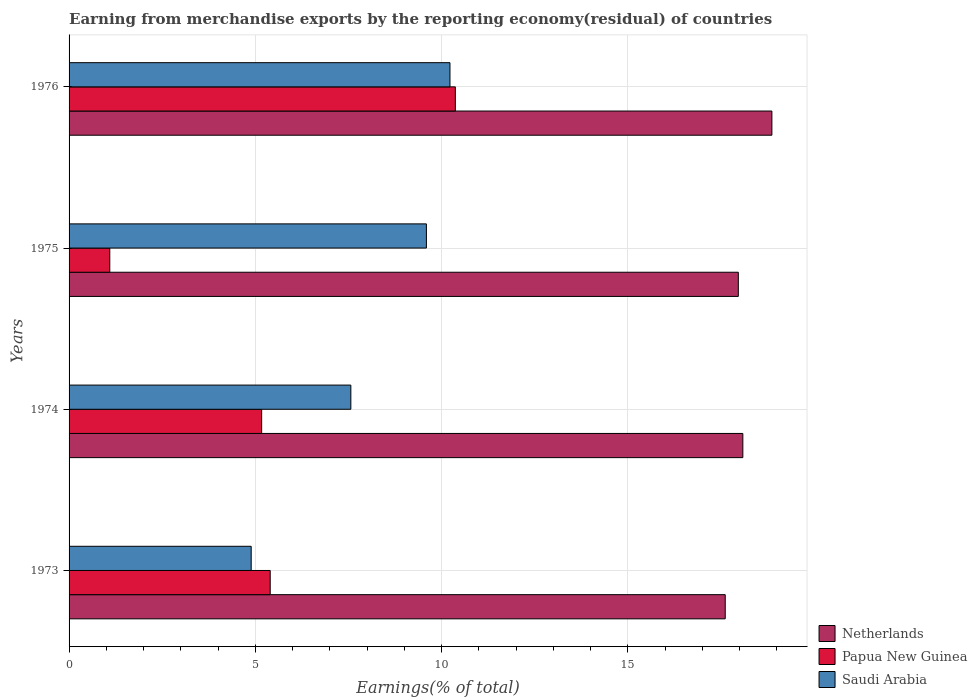How many groups of bars are there?
Give a very brief answer. 4. Are the number of bars per tick equal to the number of legend labels?
Your response must be concise. Yes. How many bars are there on the 1st tick from the top?
Ensure brevity in your answer.  3. What is the label of the 1st group of bars from the top?
Offer a very short reply. 1976. In how many cases, is the number of bars for a given year not equal to the number of legend labels?
Keep it short and to the point. 0. What is the percentage of amount earned from merchandise exports in Saudi Arabia in 1976?
Keep it short and to the point. 10.23. Across all years, what is the maximum percentage of amount earned from merchandise exports in Saudi Arabia?
Your answer should be very brief. 10.23. Across all years, what is the minimum percentage of amount earned from merchandise exports in Netherlands?
Your response must be concise. 17.62. In which year was the percentage of amount earned from merchandise exports in Netherlands maximum?
Provide a succinct answer. 1976. In which year was the percentage of amount earned from merchandise exports in Papua New Guinea minimum?
Ensure brevity in your answer.  1975. What is the total percentage of amount earned from merchandise exports in Papua New Guinea in the graph?
Your response must be concise. 22.03. What is the difference between the percentage of amount earned from merchandise exports in Netherlands in 1974 and that in 1976?
Your response must be concise. -0.78. What is the difference between the percentage of amount earned from merchandise exports in Netherlands in 1975 and the percentage of amount earned from merchandise exports in Papua New Guinea in 1976?
Make the answer very short. 7.6. What is the average percentage of amount earned from merchandise exports in Saudi Arabia per year?
Keep it short and to the point. 8.07. In the year 1974, what is the difference between the percentage of amount earned from merchandise exports in Papua New Guinea and percentage of amount earned from merchandise exports in Saudi Arabia?
Provide a short and direct response. -2.39. In how many years, is the percentage of amount earned from merchandise exports in Netherlands greater than 5 %?
Keep it short and to the point. 4. What is the ratio of the percentage of amount earned from merchandise exports in Netherlands in 1973 to that in 1975?
Make the answer very short. 0.98. What is the difference between the highest and the second highest percentage of amount earned from merchandise exports in Saudi Arabia?
Keep it short and to the point. 0.63. What is the difference between the highest and the lowest percentage of amount earned from merchandise exports in Saudi Arabia?
Your answer should be very brief. 5.34. What does the 1st bar from the top in 1976 represents?
Ensure brevity in your answer.  Saudi Arabia. What does the 2nd bar from the bottom in 1976 represents?
Provide a succinct answer. Papua New Guinea. How many bars are there?
Make the answer very short. 12. How many years are there in the graph?
Provide a short and direct response. 4. What is the difference between two consecutive major ticks on the X-axis?
Your response must be concise. 5. Does the graph contain any zero values?
Ensure brevity in your answer.  No. Does the graph contain grids?
Your answer should be very brief. Yes. How many legend labels are there?
Keep it short and to the point. 3. What is the title of the graph?
Your answer should be very brief. Earning from merchandise exports by the reporting economy(residual) of countries. What is the label or title of the X-axis?
Your response must be concise. Earnings(% of total). What is the label or title of the Y-axis?
Your answer should be very brief. Years. What is the Earnings(% of total) in Netherlands in 1973?
Your answer should be very brief. 17.62. What is the Earnings(% of total) of Papua New Guinea in 1973?
Provide a short and direct response. 5.4. What is the Earnings(% of total) of Saudi Arabia in 1973?
Keep it short and to the point. 4.89. What is the Earnings(% of total) of Netherlands in 1974?
Your answer should be very brief. 18.09. What is the Earnings(% of total) in Papua New Guinea in 1974?
Your answer should be compact. 5.17. What is the Earnings(% of total) in Saudi Arabia in 1974?
Keep it short and to the point. 7.56. What is the Earnings(% of total) in Netherlands in 1975?
Your response must be concise. 17.97. What is the Earnings(% of total) of Papua New Guinea in 1975?
Your response must be concise. 1.09. What is the Earnings(% of total) of Saudi Arabia in 1975?
Give a very brief answer. 9.59. What is the Earnings(% of total) of Netherlands in 1976?
Your response must be concise. 18.87. What is the Earnings(% of total) of Papua New Guinea in 1976?
Give a very brief answer. 10.37. What is the Earnings(% of total) in Saudi Arabia in 1976?
Provide a succinct answer. 10.23. Across all years, what is the maximum Earnings(% of total) in Netherlands?
Ensure brevity in your answer.  18.87. Across all years, what is the maximum Earnings(% of total) of Papua New Guinea?
Provide a succinct answer. 10.37. Across all years, what is the maximum Earnings(% of total) of Saudi Arabia?
Provide a succinct answer. 10.23. Across all years, what is the minimum Earnings(% of total) of Netherlands?
Offer a very short reply. 17.62. Across all years, what is the minimum Earnings(% of total) in Papua New Guinea?
Keep it short and to the point. 1.09. Across all years, what is the minimum Earnings(% of total) in Saudi Arabia?
Your response must be concise. 4.89. What is the total Earnings(% of total) of Netherlands in the graph?
Make the answer very short. 72.54. What is the total Earnings(% of total) in Papua New Guinea in the graph?
Provide a succinct answer. 22.03. What is the total Earnings(% of total) of Saudi Arabia in the graph?
Give a very brief answer. 32.27. What is the difference between the Earnings(% of total) of Netherlands in 1973 and that in 1974?
Provide a short and direct response. -0.47. What is the difference between the Earnings(% of total) of Papua New Guinea in 1973 and that in 1974?
Keep it short and to the point. 0.23. What is the difference between the Earnings(% of total) of Saudi Arabia in 1973 and that in 1974?
Provide a short and direct response. -2.68. What is the difference between the Earnings(% of total) of Netherlands in 1973 and that in 1975?
Give a very brief answer. -0.35. What is the difference between the Earnings(% of total) of Papua New Guinea in 1973 and that in 1975?
Provide a succinct answer. 4.31. What is the difference between the Earnings(% of total) in Saudi Arabia in 1973 and that in 1975?
Ensure brevity in your answer.  -4.7. What is the difference between the Earnings(% of total) of Netherlands in 1973 and that in 1976?
Your answer should be compact. -1.25. What is the difference between the Earnings(% of total) of Papua New Guinea in 1973 and that in 1976?
Your response must be concise. -4.97. What is the difference between the Earnings(% of total) in Saudi Arabia in 1973 and that in 1976?
Offer a terse response. -5.34. What is the difference between the Earnings(% of total) of Netherlands in 1974 and that in 1975?
Make the answer very short. 0.12. What is the difference between the Earnings(% of total) of Papua New Guinea in 1974 and that in 1975?
Your response must be concise. 4.08. What is the difference between the Earnings(% of total) in Saudi Arabia in 1974 and that in 1975?
Offer a very short reply. -2.03. What is the difference between the Earnings(% of total) of Netherlands in 1974 and that in 1976?
Offer a very short reply. -0.78. What is the difference between the Earnings(% of total) of Papua New Guinea in 1974 and that in 1976?
Ensure brevity in your answer.  -5.2. What is the difference between the Earnings(% of total) of Saudi Arabia in 1974 and that in 1976?
Offer a terse response. -2.66. What is the difference between the Earnings(% of total) of Netherlands in 1975 and that in 1976?
Provide a short and direct response. -0.9. What is the difference between the Earnings(% of total) in Papua New Guinea in 1975 and that in 1976?
Give a very brief answer. -9.28. What is the difference between the Earnings(% of total) of Saudi Arabia in 1975 and that in 1976?
Provide a short and direct response. -0.63. What is the difference between the Earnings(% of total) of Netherlands in 1973 and the Earnings(% of total) of Papua New Guinea in 1974?
Make the answer very short. 12.45. What is the difference between the Earnings(% of total) of Netherlands in 1973 and the Earnings(% of total) of Saudi Arabia in 1974?
Provide a short and direct response. 10.05. What is the difference between the Earnings(% of total) in Papua New Guinea in 1973 and the Earnings(% of total) in Saudi Arabia in 1974?
Give a very brief answer. -2.16. What is the difference between the Earnings(% of total) of Netherlands in 1973 and the Earnings(% of total) of Papua New Guinea in 1975?
Provide a succinct answer. 16.52. What is the difference between the Earnings(% of total) of Netherlands in 1973 and the Earnings(% of total) of Saudi Arabia in 1975?
Offer a very short reply. 8.02. What is the difference between the Earnings(% of total) of Papua New Guinea in 1973 and the Earnings(% of total) of Saudi Arabia in 1975?
Keep it short and to the point. -4.19. What is the difference between the Earnings(% of total) in Netherlands in 1973 and the Earnings(% of total) in Papua New Guinea in 1976?
Ensure brevity in your answer.  7.25. What is the difference between the Earnings(% of total) of Netherlands in 1973 and the Earnings(% of total) of Saudi Arabia in 1976?
Give a very brief answer. 7.39. What is the difference between the Earnings(% of total) in Papua New Guinea in 1973 and the Earnings(% of total) in Saudi Arabia in 1976?
Ensure brevity in your answer.  -4.83. What is the difference between the Earnings(% of total) of Netherlands in 1974 and the Earnings(% of total) of Papua New Guinea in 1975?
Your response must be concise. 17. What is the difference between the Earnings(% of total) in Netherlands in 1974 and the Earnings(% of total) in Saudi Arabia in 1975?
Your response must be concise. 8.5. What is the difference between the Earnings(% of total) of Papua New Guinea in 1974 and the Earnings(% of total) of Saudi Arabia in 1975?
Keep it short and to the point. -4.42. What is the difference between the Earnings(% of total) in Netherlands in 1974 and the Earnings(% of total) in Papua New Guinea in 1976?
Ensure brevity in your answer.  7.72. What is the difference between the Earnings(% of total) in Netherlands in 1974 and the Earnings(% of total) in Saudi Arabia in 1976?
Make the answer very short. 7.86. What is the difference between the Earnings(% of total) in Papua New Guinea in 1974 and the Earnings(% of total) in Saudi Arabia in 1976?
Offer a terse response. -5.06. What is the difference between the Earnings(% of total) of Netherlands in 1975 and the Earnings(% of total) of Papua New Guinea in 1976?
Keep it short and to the point. 7.6. What is the difference between the Earnings(% of total) of Netherlands in 1975 and the Earnings(% of total) of Saudi Arabia in 1976?
Provide a succinct answer. 7.74. What is the difference between the Earnings(% of total) of Papua New Guinea in 1975 and the Earnings(% of total) of Saudi Arabia in 1976?
Keep it short and to the point. -9.13. What is the average Earnings(% of total) in Netherlands per year?
Offer a terse response. 18.14. What is the average Earnings(% of total) of Papua New Guinea per year?
Make the answer very short. 5.51. What is the average Earnings(% of total) in Saudi Arabia per year?
Make the answer very short. 8.07. In the year 1973, what is the difference between the Earnings(% of total) in Netherlands and Earnings(% of total) in Papua New Guinea?
Your answer should be very brief. 12.22. In the year 1973, what is the difference between the Earnings(% of total) in Netherlands and Earnings(% of total) in Saudi Arabia?
Make the answer very short. 12.73. In the year 1973, what is the difference between the Earnings(% of total) of Papua New Guinea and Earnings(% of total) of Saudi Arabia?
Provide a short and direct response. 0.51. In the year 1974, what is the difference between the Earnings(% of total) of Netherlands and Earnings(% of total) of Papua New Guinea?
Your answer should be compact. 12.92. In the year 1974, what is the difference between the Earnings(% of total) of Netherlands and Earnings(% of total) of Saudi Arabia?
Your response must be concise. 10.52. In the year 1974, what is the difference between the Earnings(% of total) of Papua New Guinea and Earnings(% of total) of Saudi Arabia?
Provide a succinct answer. -2.39. In the year 1975, what is the difference between the Earnings(% of total) of Netherlands and Earnings(% of total) of Papua New Guinea?
Provide a succinct answer. 16.87. In the year 1975, what is the difference between the Earnings(% of total) of Netherlands and Earnings(% of total) of Saudi Arabia?
Your answer should be compact. 8.37. In the year 1975, what is the difference between the Earnings(% of total) of Papua New Guinea and Earnings(% of total) of Saudi Arabia?
Make the answer very short. -8.5. In the year 1976, what is the difference between the Earnings(% of total) in Netherlands and Earnings(% of total) in Papua New Guinea?
Keep it short and to the point. 8.5. In the year 1976, what is the difference between the Earnings(% of total) of Netherlands and Earnings(% of total) of Saudi Arabia?
Ensure brevity in your answer.  8.64. In the year 1976, what is the difference between the Earnings(% of total) of Papua New Guinea and Earnings(% of total) of Saudi Arabia?
Provide a short and direct response. 0.14. What is the ratio of the Earnings(% of total) of Netherlands in 1973 to that in 1974?
Give a very brief answer. 0.97. What is the ratio of the Earnings(% of total) in Papua New Guinea in 1973 to that in 1974?
Provide a short and direct response. 1.04. What is the ratio of the Earnings(% of total) of Saudi Arabia in 1973 to that in 1974?
Make the answer very short. 0.65. What is the ratio of the Earnings(% of total) of Netherlands in 1973 to that in 1975?
Offer a very short reply. 0.98. What is the ratio of the Earnings(% of total) in Papua New Guinea in 1973 to that in 1975?
Give a very brief answer. 4.94. What is the ratio of the Earnings(% of total) of Saudi Arabia in 1973 to that in 1975?
Offer a very short reply. 0.51. What is the ratio of the Earnings(% of total) in Netherlands in 1973 to that in 1976?
Your response must be concise. 0.93. What is the ratio of the Earnings(% of total) in Papua New Guinea in 1973 to that in 1976?
Offer a terse response. 0.52. What is the ratio of the Earnings(% of total) of Saudi Arabia in 1973 to that in 1976?
Your response must be concise. 0.48. What is the ratio of the Earnings(% of total) of Netherlands in 1974 to that in 1975?
Provide a short and direct response. 1.01. What is the ratio of the Earnings(% of total) of Papua New Guinea in 1974 to that in 1975?
Offer a terse response. 4.73. What is the ratio of the Earnings(% of total) in Saudi Arabia in 1974 to that in 1975?
Your response must be concise. 0.79. What is the ratio of the Earnings(% of total) in Netherlands in 1974 to that in 1976?
Your response must be concise. 0.96. What is the ratio of the Earnings(% of total) in Papua New Guinea in 1974 to that in 1976?
Your response must be concise. 0.5. What is the ratio of the Earnings(% of total) of Saudi Arabia in 1974 to that in 1976?
Offer a terse response. 0.74. What is the ratio of the Earnings(% of total) of Netherlands in 1975 to that in 1976?
Provide a short and direct response. 0.95. What is the ratio of the Earnings(% of total) of Papua New Guinea in 1975 to that in 1976?
Give a very brief answer. 0.11. What is the ratio of the Earnings(% of total) of Saudi Arabia in 1975 to that in 1976?
Your answer should be very brief. 0.94. What is the difference between the highest and the second highest Earnings(% of total) in Netherlands?
Make the answer very short. 0.78. What is the difference between the highest and the second highest Earnings(% of total) in Papua New Guinea?
Offer a terse response. 4.97. What is the difference between the highest and the second highest Earnings(% of total) in Saudi Arabia?
Your answer should be compact. 0.63. What is the difference between the highest and the lowest Earnings(% of total) of Netherlands?
Offer a very short reply. 1.25. What is the difference between the highest and the lowest Earnings(% of total) of Papua New Guinea?
Your answer should be compact. 9.28. What is the difference between the highest and the lowest Earnings(% of total) in Saudi Arabia?
Your answer should be compact. 5.34. 